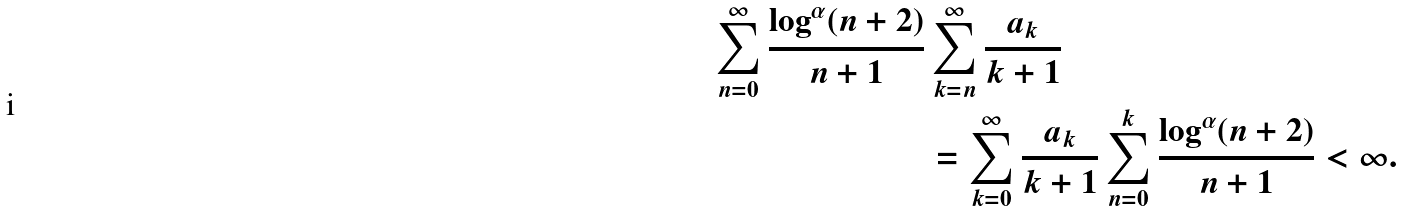Convert formula to latex. <formula><loc_0><loc_0><loc_500><loc_500>\sum _ { n = 0 } ^ { \infty } \frac { \log ^ { \alpha } ( n + 2 ) } { n + 1 } & \sum _ { k = n } ^ { \infty } \frac { a _ { k } } { k + 1 } \\ & = \sum _ { k = 0 } ^ { \infty } \frac { a _ { k } } { k + 1 } \sum _ { n = 0 } ^ { k } \frac { \log ^ { \alpha } ( n + 2 ) } { n + 1 } < \infty .</formula> 